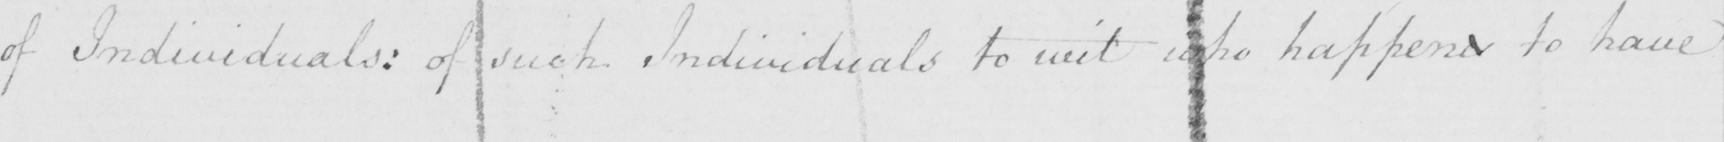What text is written in this handwritten line? of Individuals :  of such Individuals to wit who happens to have 